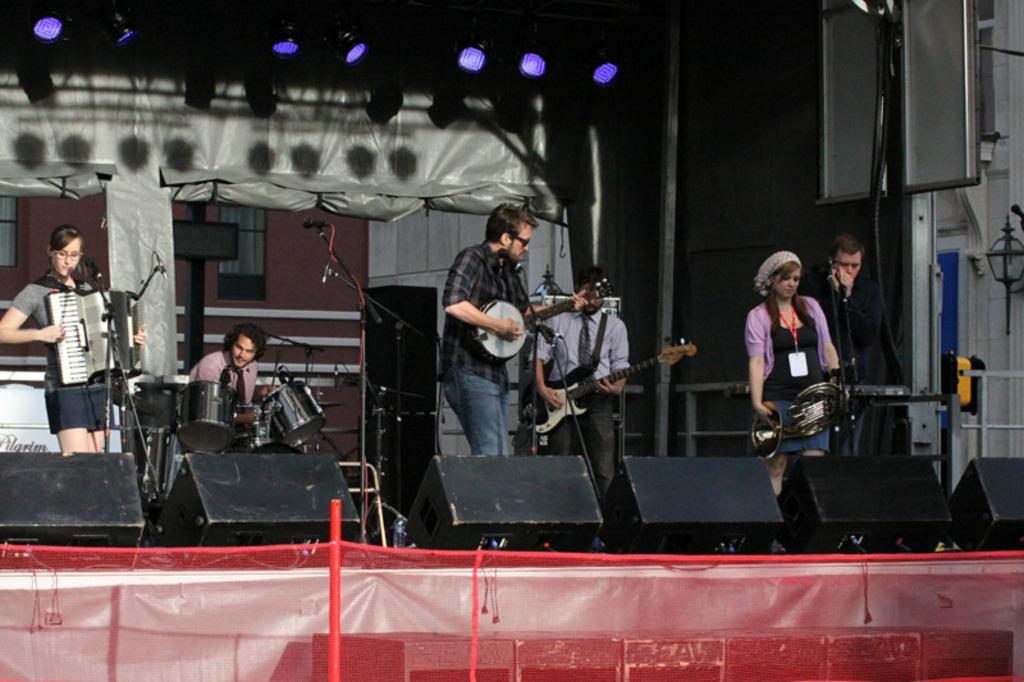What is happening in the image? There are people in the image, and they are playing musical instruments. What are the people doing while playing the musical instruments? The provided facts do not specify any additional actions or context, so we can only say that they are playing musical instruments. What is the purpose of the voyage in the image? There is no voyage or any indication of travel in the image; it simply shows people playing musical instruments. 